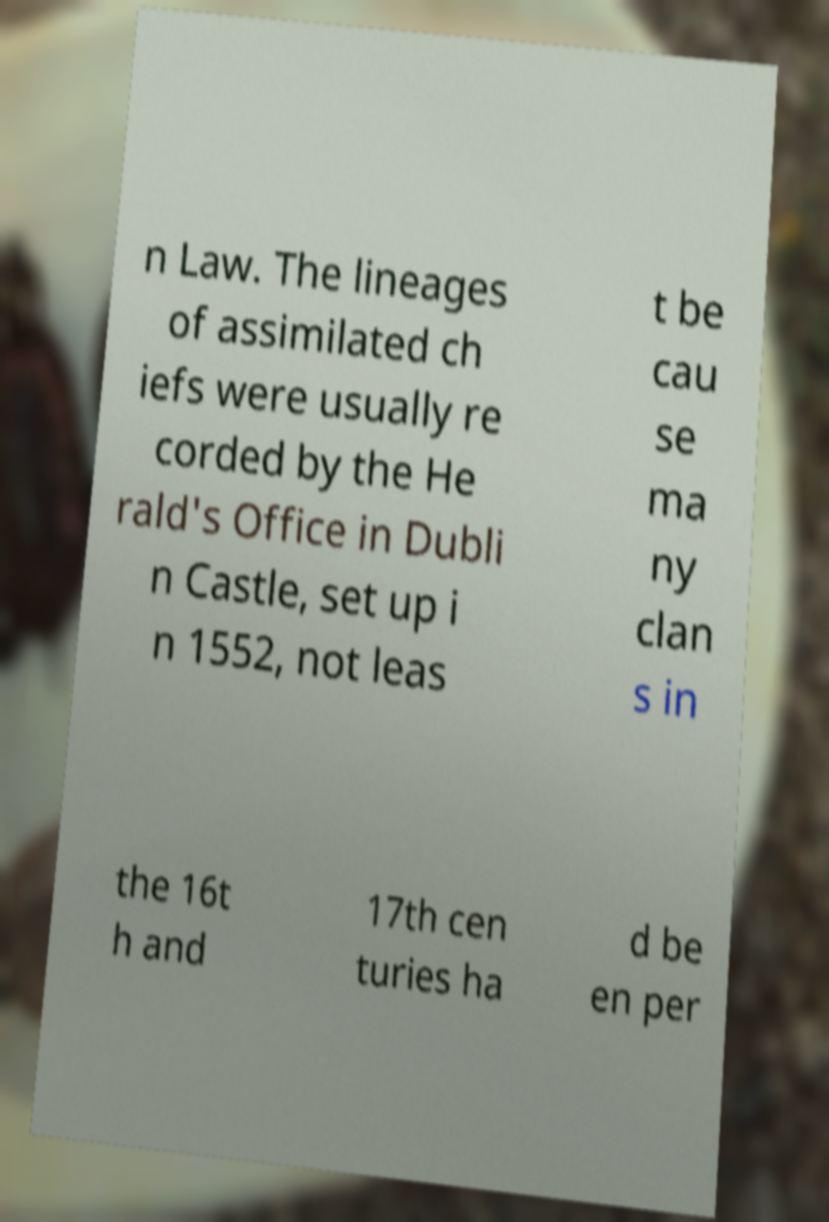Could you extract and type out the text from this image? n Law. The lineages of assimilated ch iefs were usually re corded by the He rald's Office in Dubli n Castle, set up i n 1552, not leas t be cau se ma ny clan s in the 16t h and 17th cen turies ha d be en per 